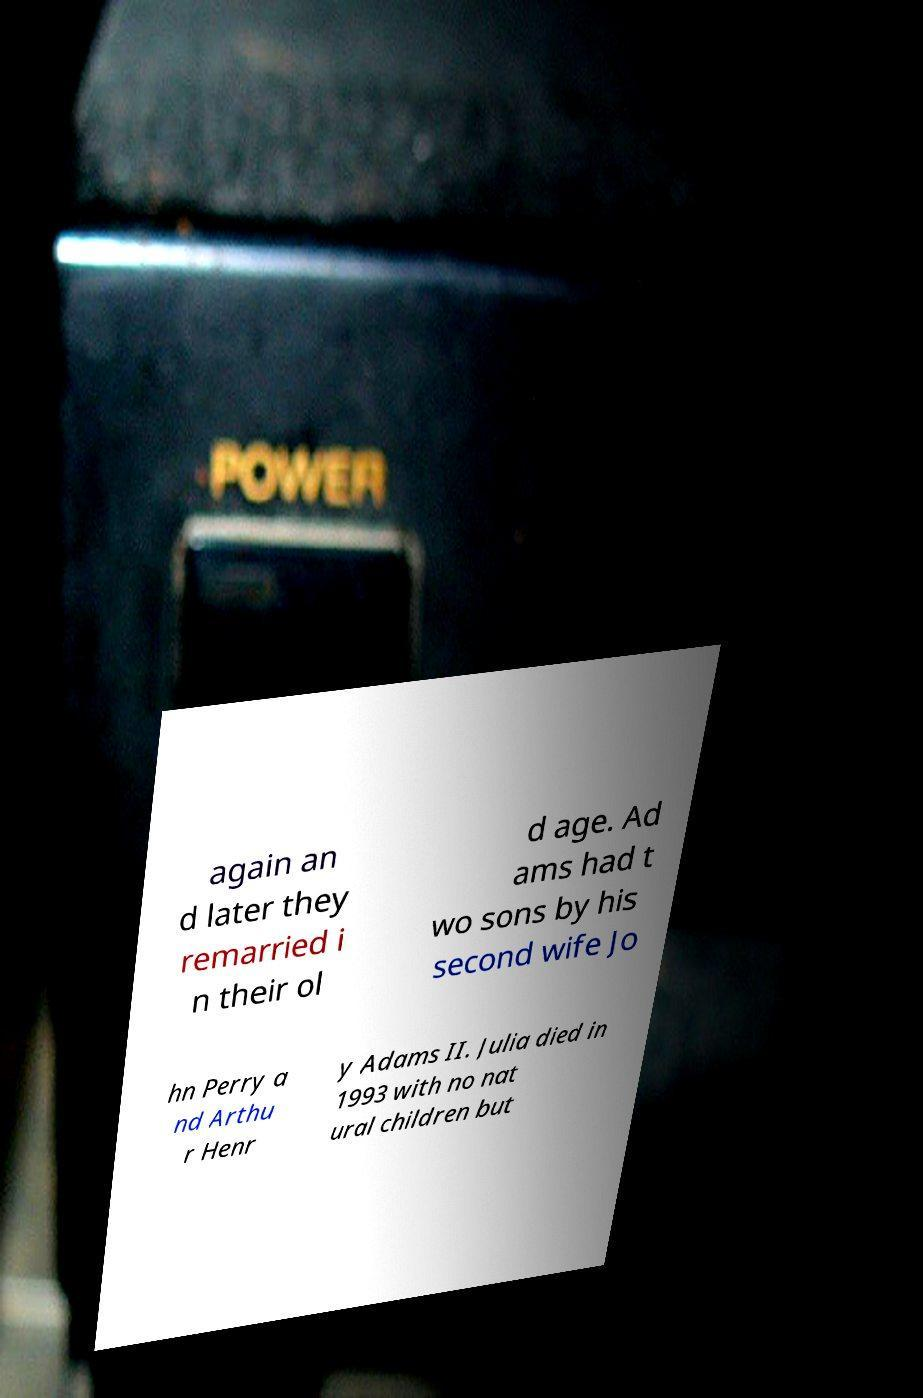For documentation purposes, I need the text within this image transcribed. Could you provide that? again an d later they remarried i n their ol d age. Ad ams had t wo sons by his second wife Jo hn Perry a nd Arthu r Henr y Adams II. Julia died in 1993 with no nat ural children but 